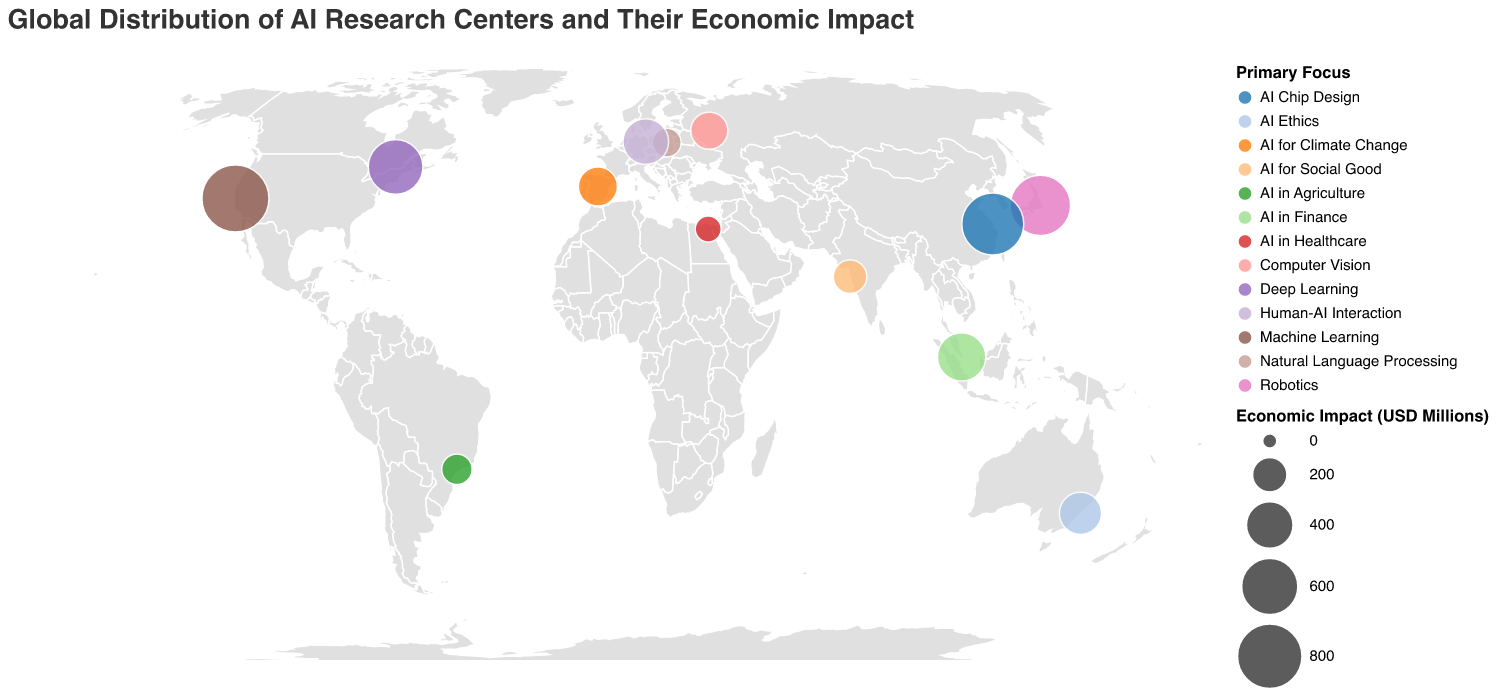What's the title of the figure? The title is usually displayed prominently at the top of the figure. Readers can quickly identify it by looking for a larger or bold font that stands out.
Answer: Global Distribution of AI Research Centers and Their Economic Impact Which AI research center has the highest economic impact? Locate the data points with the largest circles, as circle size represents economic impact. Upon examining the largest circles, identify the corresponding tooltip information or legend.
Answer: Stanford AI Lab What is the primary focus of the AI research center in Tokyo, Japan? By locating Tokyo, Japan on the map and examining the tooltip information or checking the relevant data point, you can identify the primary focus of the research center.
Answer: Robotics How many AI research centers have an economic impact greater than 500 million USD? Examine the sizes of the circles (which visually represent the economic impact) and count the number of circles whose size corresponds to impacts greater than 500 million USD according to the scale provided in the legend.
Answer: Four Which continent has the most AI research centers represented in the figure? Visually count the number of data points (circles) on each continent by examining their geographical locations on the map. Compare the counts to determine which continent has the highest number.
Answer: Asia What is the combined economic impact of AI research centers in the USA and Canada? Find and sum the economic impacts of relevant research centers by examining their tooltip information. The centers are Stanford AI Lab (850 million USD) and Mila (550 million USD). Thus, 850 + 550 = 1400.
Answer: 1400 million USD Which research center focuses on AI in Finance, and where is it located? By examining the tooltip information or the legend that maps color to "Primary Focus", locate the point indicating "AI in Finance" and note the associated city and country.
Answer: AI Singapore, Singapore How does the economic impact of the AI research center in Moscow compare to that in Berlin? Identify and compare the circles representing Moscow and Berlin by examining their economic impacts through the tooltip information.
Answer: Moscow's (230 million USD) is less than Berlin's (370 million USD) What's the approximate longitude of the AI research center in Cairo, Egypt? Locate Cairo, Egypt on the map and check the tooltip information for the longitude value.
Answer: Approximately 31.2357 What primary focus appears to be the most common among the AI research centers on the map? Examine the color representation for each "Primary Focus" in the legend, and count the frequency of each color appearing on the map. The focus with the highest count is the most common.
Answer: Varies based on actual frequencies observed 